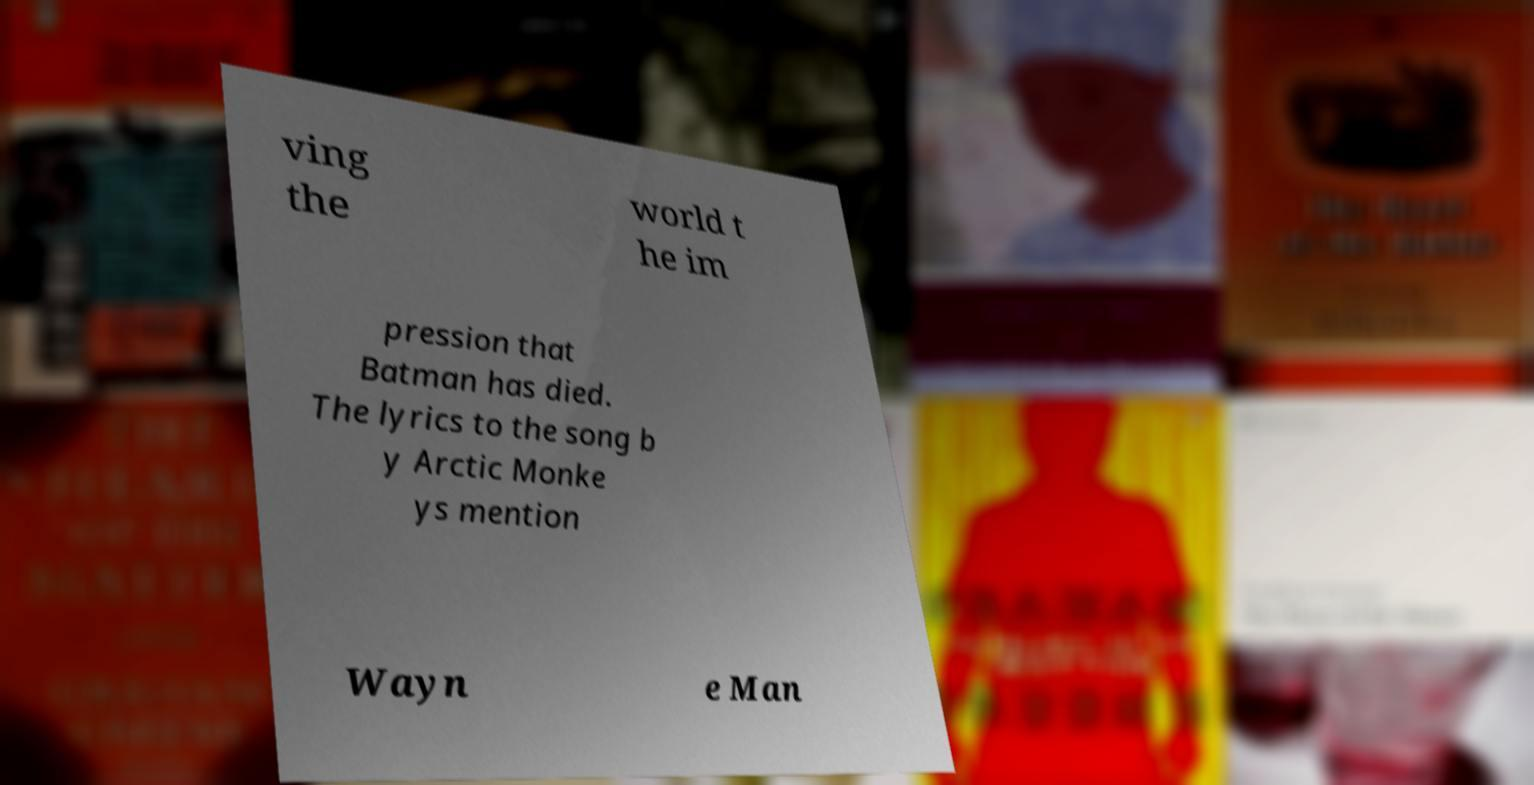I need the written content from this picture converted into text. Can you do that? ving the world t he im pression that Batman has died. The lyrics to the song b y Arctic Monke ys mention Wayn e Man 